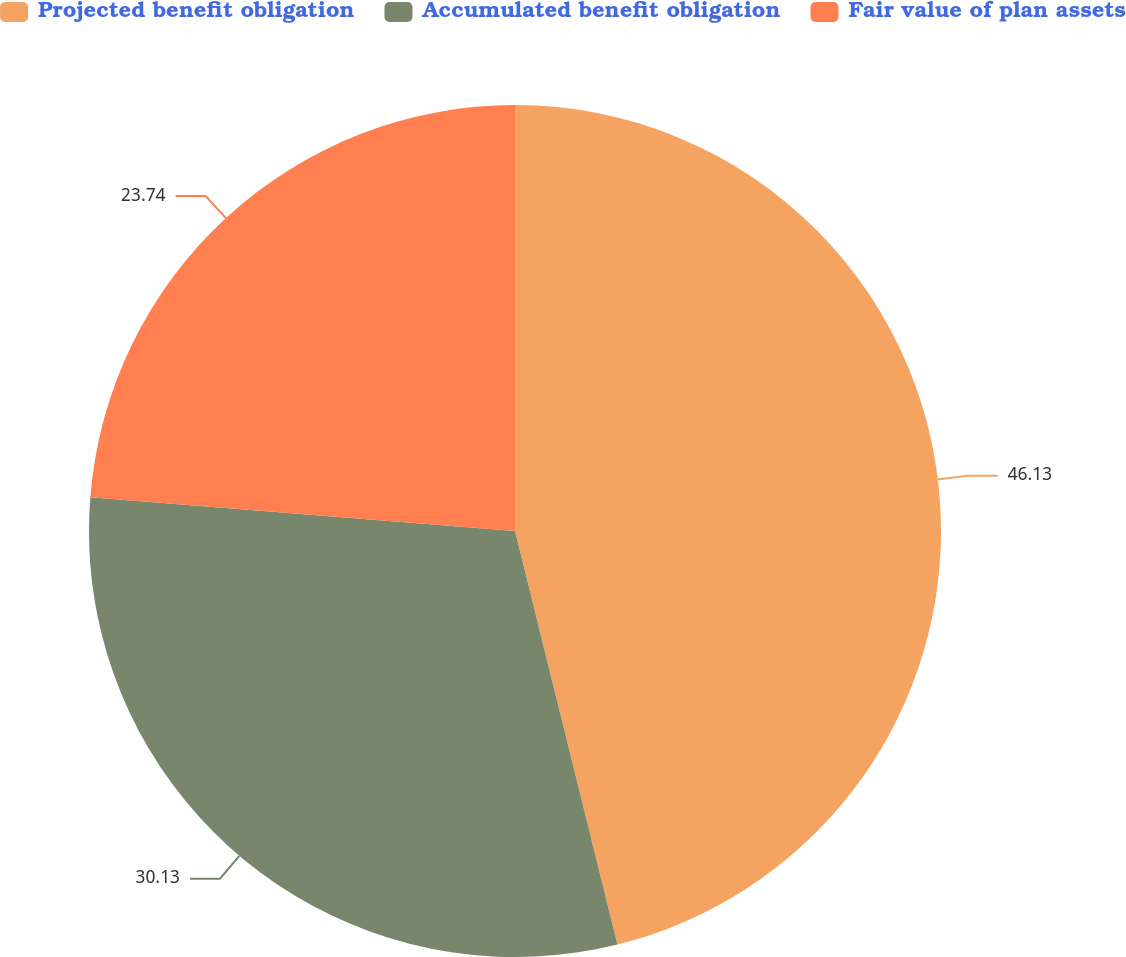Convert chart. <chart><loc_0><loc_0><loc_500><loc_500><pie_chart><fcel>Projected benefit obligation<fcel>Accumulated benefit obligation<fcel>Fair value of plan assets<nl><fcel>46.14%<fcel>30.13%<fcel>23.74%<nl></chart> 